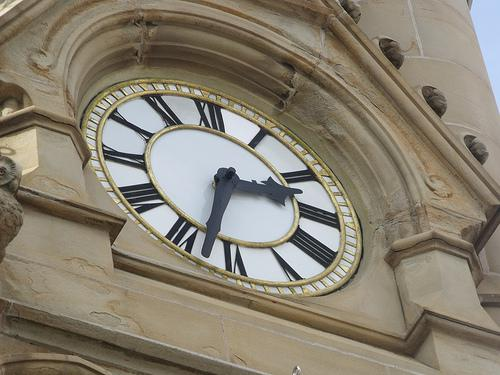Question: where are the clock hands?
Choices:
A. At 3 o'clock.
B. At 12 o'clock.
C. On clock.
D. At 6:30.
Answer with the letter. Answer: C Question: where is the border?
Choices:
A. Around the window.
B. Under the trim.
C. Around clock.
D. Around the picture.
Answer with the letter. Answer: C Question: what color is clock border?
Choices:
A. Silver.
B. Gold.
C. Red.
D. Black.
Answer with the letter. Answer: B Question: what color are the roman numbers?
Choices:
A. Purple.
B. Black.
C. Red.
D. Yellow.
Answer with the letter. Answer: B Question: what is the building made of?
Choices:
A. Brick.
B. Wood.
C. Stone.
D. Clay.
Answer with the letter. Answer: C 